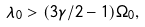Convert formula to latex. <formula><loc_0><loc_0><loc_500><loc_500>\lambda _ { 0 } > ( 3 \gamma / 2 - 1 ) \Omega _ { 0 } ,</formula> 